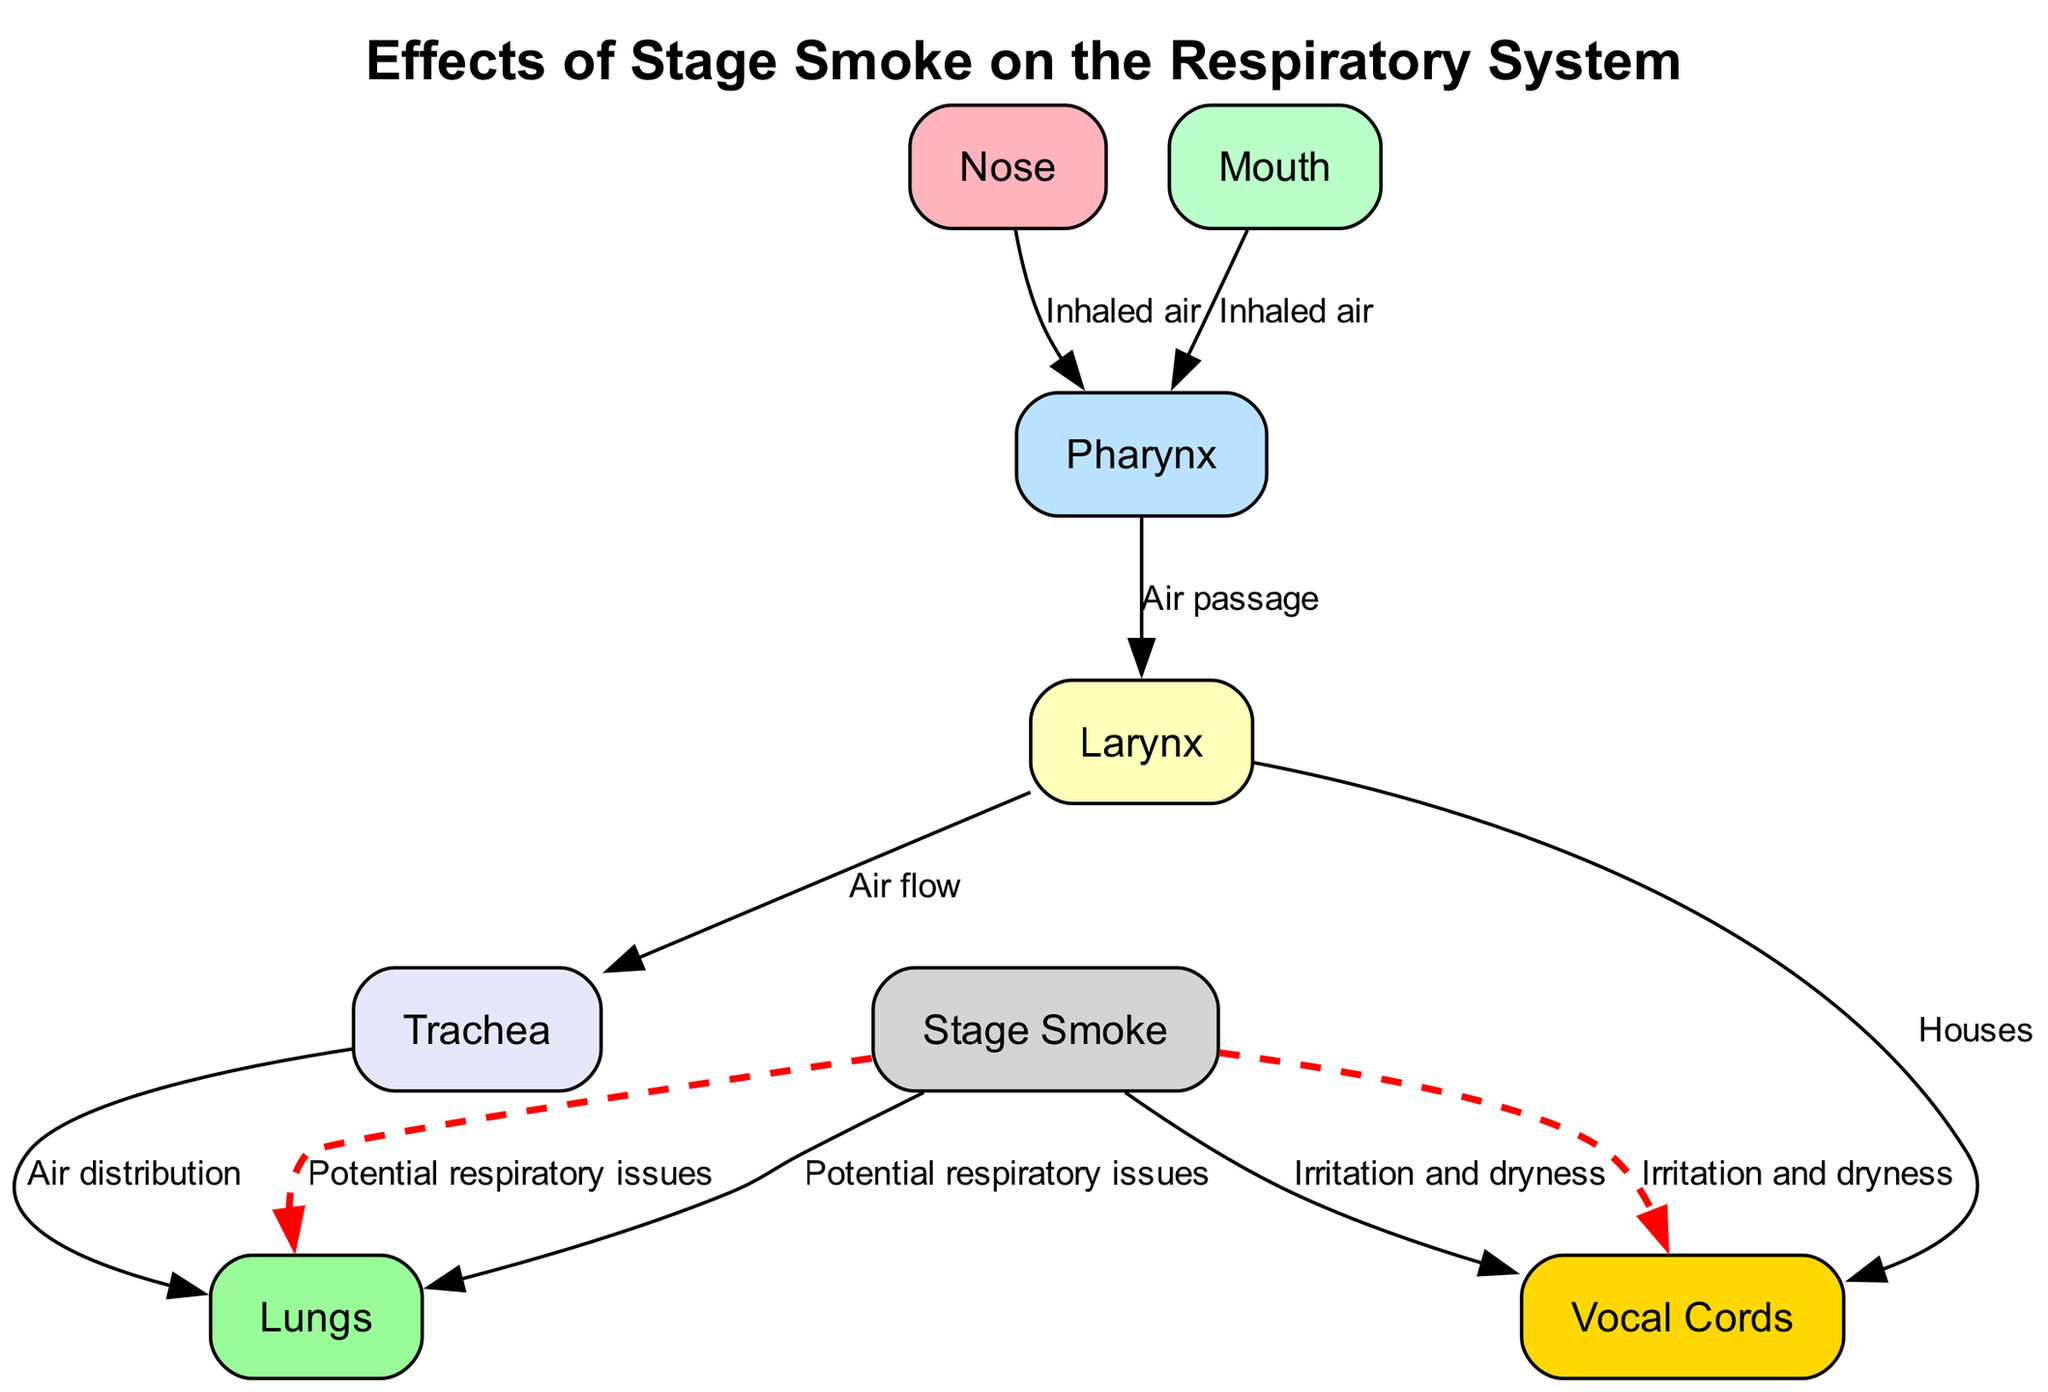What is the first structure in the inhalation pathway? The inhalation pathway starts at the "Nose," as depicted at the top of the diagram. It is the first node where air enters.
Answer: Nose How many nodes are in the diagram? The diagram contains eight nodes, as listed in the data provided, including structures of the respiratory system and stage smoke.
Answer: Eight What color represents the vocal cords? The vocal cords in the diagram are represented with a gold color, specifically the hex code #FFD700.
Answer: Gold What does stage smoke cause to the vocal cords? The diagram indicates that stage smoke results in "Irritation and dryness" to the vocal cords, as shown by the edge labeled in red.
Answer: Irritation and dryness Which two structures receive the effects from stage smoke? According to the diagram, the "Vocal Cords" and "Lungs" are affected by stage smoke, as indicated by the two edges stemming from the stage smoke node.
Answer: Vocal cords and lungs What is the purpose of the larynx in the airflow process? In the airflow process, the larynx serves as a housing structure for the vocal cords while also directing air flow towards the trachea for further distribution.
Answer: Houses and directs air flow What type of problems can stage smoke potentially cause in the lungs? The diagram states that stage smoke can cause "Potential respiratory issues" in the lungs, highlighting the risks associated with exposure.
Answer: Potential respiratory issues What structure connects the pharynx to the lungs? The "Trachea" connects the pharynx to the lungs, as indicated by the directed edge labeled "Air distribution."
Answer: Trachea How is air inhaled through the mouth related to the pharynx? The air inhaled through the mouth travels directly to the pharynx, as shown by the edge labeled "Inhaled air" connecting the mouth to the pharynx.
Answer: Inhaled air 